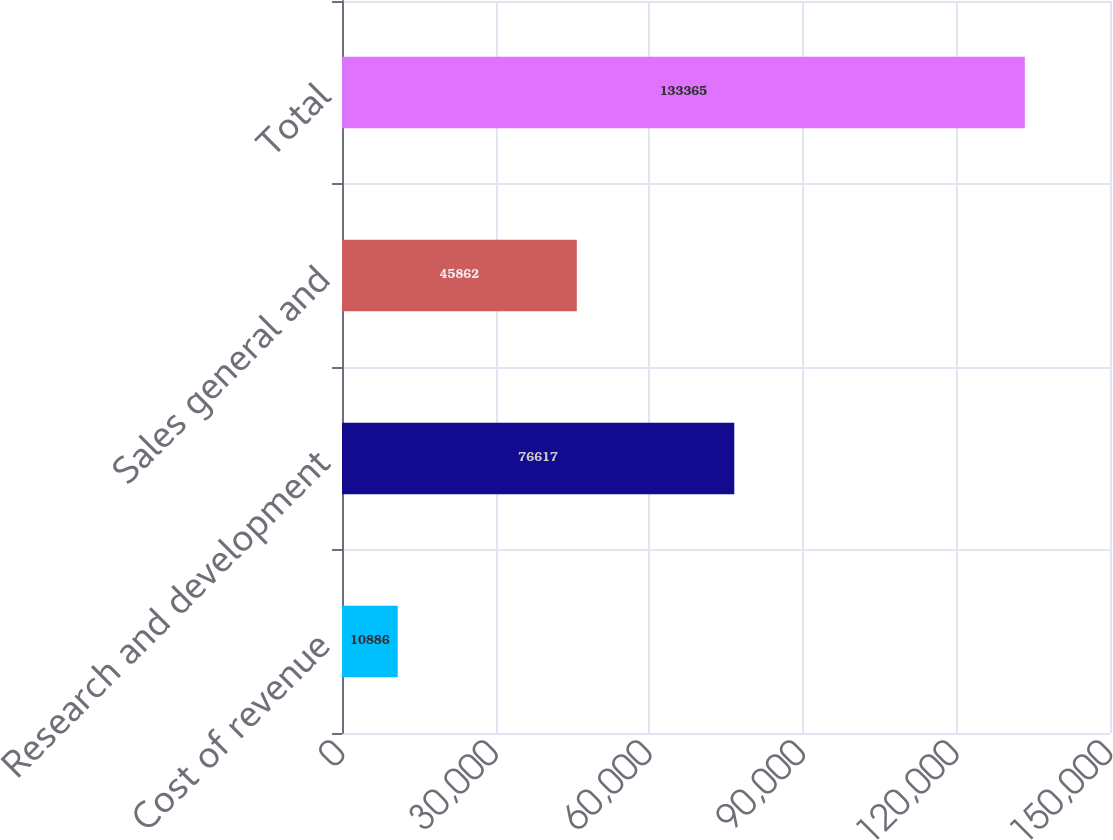Convert chart to OTSL. <chart><loc_0><loc_0><loc_500><loc_500><bar_chart><fcel>Cost of revenue<fcel>Research and development<fcel>Sales general and<fcel>Total<nl><fcel>10886<fcel>76617<fcel>45862<fcel>133365<nl></chart> 